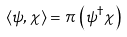Convert formula to latex. <formula><loc_0><loc_0><loc_500><loc_500>\langle \psi , \chi \rangle = \pi \, \left ( \psi ^ { \dagger } \chi \right )</formula> 